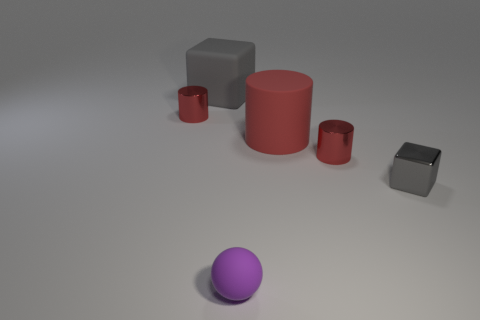How many red cylinders must be subtracted to get 1 red cylinders? 2 Subtract all tiny cylinders. How many cylinders are left? 1 Add 4 small blocks. How many objects exist? 10 Subtract all blocks. How many objects are left? 4 Subtract 0 blue cylinders. How many objects are left? 6 Subtract 1 spheres. How many spheres are left? 0 Subtract all yellow cubes. Subtract all brown balls. How many cubes are left? 2 Subtract all small gray shiny objects. Subtract all blocks. How many objects are left? 3 Add 6 large rubber objects. How many large rubber objects are left? 8 Add 4 rubber cylinders. How many rubber cylinders exist? 5 